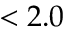Convert formula to latex. <formula><loc_0><loc_0><loc_500><loc_500>< 2 . 0</formula> 